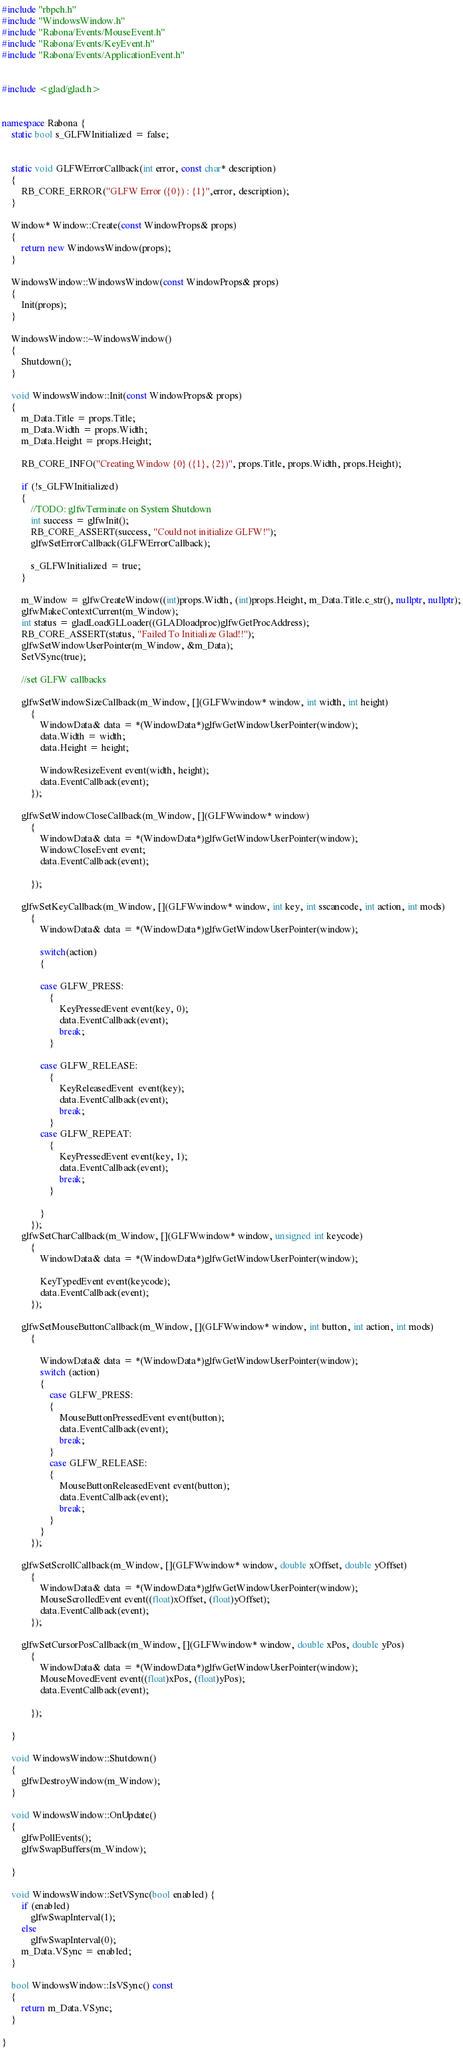<code> <loc_0><loc_0><loc_500><loc_500><_C++_>#include "rbpch.h"
#include "WindowsWindow.h"
#include "Rabona/Events/MouseEvent.h"
#include "Rabona/Events/KeyEvent.h"
#include "Rabona/Events/ApplicationEvent.h"


#include <glad/glad.h>


namespace Rabona {
	static bool s_GLFWInitialized = false;

	
	static void GLFWErrorCallback(int error, const char* description)
	{
		RB_CORE_ERROR("GLFW Error ({0}) : {1}",error, description);
	}

	Window* Window::Create(const WindowProps& props)
	{
		return new WindowsWindow(props);
	}

	WindowsWindow::WindowsWindow(const WindowProps& props)
	{
		Init(props);
	}

	WindowsWindow::~WindowsWindow()
	{
		Shutdown();
	}

	void WindowsWindow::Init(const WindowProps& props)
	{
		m_Data.Title = props.Title;
		m_Data.Width = props.Width;
		m_Data.Height = props.Height;

		RB_CORE_INFO("Creating Window {0} ({1}, {2})", props.Title, props.Width, props.Height);

		if (!s_GLFWInitialized)
		{
			//TODO: glfwTerminate on System Shutdown
			int success = glfwInit();
			RB_CORE_ASSERT(success, "Could not initialize GLFW!");
			glfwSetErrorCallback(GLFWErrorCallback);

			s_GLFWInitialized = true;
		}

		m_Window = glfwCreateWindow((int)props.Width, (int)props.Height, m_Data.Title.c_str(), nullptr, nullptr);
		glfwMakeContextCurrent(m_Window);
		int status = gladLoadGLLoader((GLADloadproc)glfwGetProcAddress);
		RB_CORE_ASSERT(status, "Failed To Initialize Glad!!");
		glfwSetWindowUserPointer(m_Window, &m_Data);
		SetVSync(true);
	
		//set GLFW callbacks

		glfwSetWindowSizeCallback(m_Window, [](GLFWwindow* window, int width, int height)
			{
				WindowData& data = *(WindowData*)glfwGetWindowUserPointer(window);
				data.Width = width;
				data.Height = height;
				
				WindowResizeEvent event(width, height);
				data.EventCallback(event);
			});

		glfwSetWindowCloseCallback(m_Window, [](GLFWwindow* window)
			{
				WindowData& data = *(WindowData*)glfwGetWindowUserPointer(window);
				WindowCloseEvent event;
				data.EventCallback(event);

			});

		glfwSetKeyCallback(m_Window, [](GLFWwindow* window, int key, int sscancode, int action, int mods)
			{
				WindowData& data = *(WindowData*)glfwGetWindowUserPointer(window);

				switch(action)
				{
					
				case GLFW_PRESS:
					{
						KeyPressedEvent event(key, 0);
						data.EventCallback(event);
						break;
					}

				case GLFW_RELEASE:
					{
						KeyReleasedEvent  event(key);
						data.EventCallback(event);
						break;
					}
				case GLFW_REPEAT:
					{
						KeyPressedEvent event(key, 1);
						data.EventCallback(event);
						break;
					}

				}
			});
		glfwSetCharCallback(m_Window, [](GLFWwindow* window, unsigned int keycode)
			{
				WindowData& data = *(WindowData*)glfwGetWindowUserPointer(window);

				KeyTypedEvent event(keycode);
				data.EventCallback(event);
			});

		glfwSetMouseButtonCallback(m_Window, [](GLFWwindow* window, int button, int action, int mods)
			{
				
				WindowData& data = *(WindowData*)glfwGetWindowUserPointer(window);
				switch (action)
				{
					case GLFW_PRESS:
					{
						MouseButtonPressedEvent event(button);
						data.EventCallback(event);
						break;
					}
					case GLFW_RELEASE:
					{
						MouseButtonReleasedEvent event(button);
						data.EventCallback(event);
						break;
					}
				}
			});

		glfwSetScrollCallback(m_Window, [](GLFWwindow* window, double xOffset, double yOffset)
			{
				WindowData& data = *(WindowData*)glfwGetWindowUserPointer(window);
				MouseScrolledEvent event((float)xOffset, (float)yOffset);
				data.EventCallback(event);
			});

		glfwSetCursorPosCallback(m_Window, [](GLFWwindow* window, double xPos, double yPos)
			{
				WindowData& data = *(WindowData*)glfwGetWindowUserPointer(window);
				MouseMovedEvent event((float)xPos, (float)yPos);
				data.EventCallback(event);

			});

	}	

	void WindowsWindow::Shutdown()
	{
		glfwDestroyWindow(m_Window);
	}

	void WindowsWindow::OnUpdate()
	{
		glfwPollEvents();
		glfwSwapBuffers(m_Window);

	}

	void WindowsWindow::SetVSync(bool enabled) {
		if (enabled)
			glfwSwapInterval(1);
		else
			glfwSwapInterval(0);
		m_Data.VSync = enabled;
	}

	bool WindowsWindow::IsVSync() const
	{
		return m_Data.VSync;
	}

}</code> 